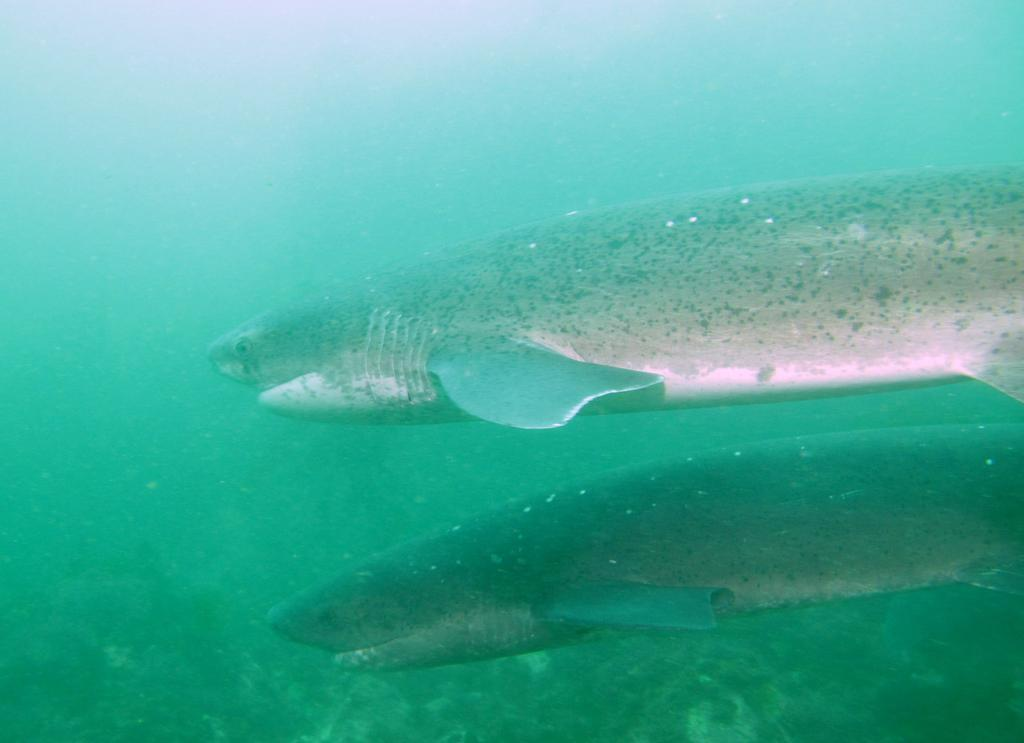What animals can be seen in the image? There are two fishes in the image. What type of environment is depicted in the image? The image shows grass in the water. What type of lipstick is the fish wearing in the image? There is no lipstick or any indication of makeup on the fish in the image. 